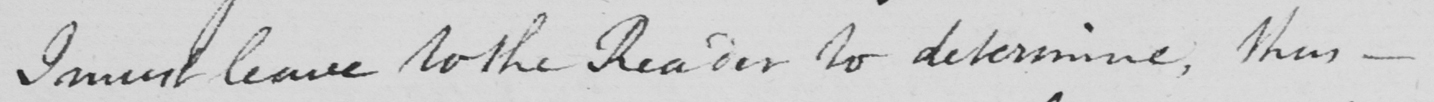Can you tell me what this handwritten text says? I must leave to the Reader to determine , thus  _ 